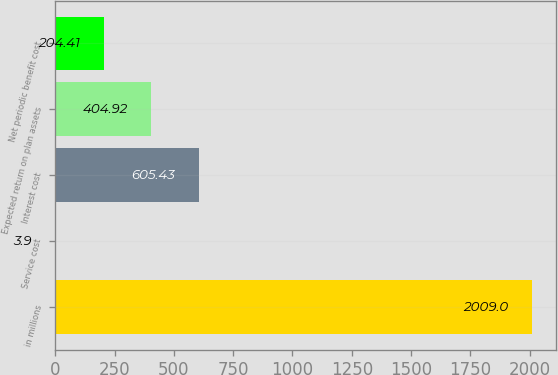Convert chart. <chart><loc_0><loc_0><loc_500><loc_500><bar_chart><fcel>in millions<fcel>Service cost<fcel>Interest cost<fcel>Expected return on plan assets<fcel>Net periodic benefit cost<nl><fcel>2009<fcel>3.9<fcel>605.43<fcel>404.92<fcel>204.41<nl></chart> 